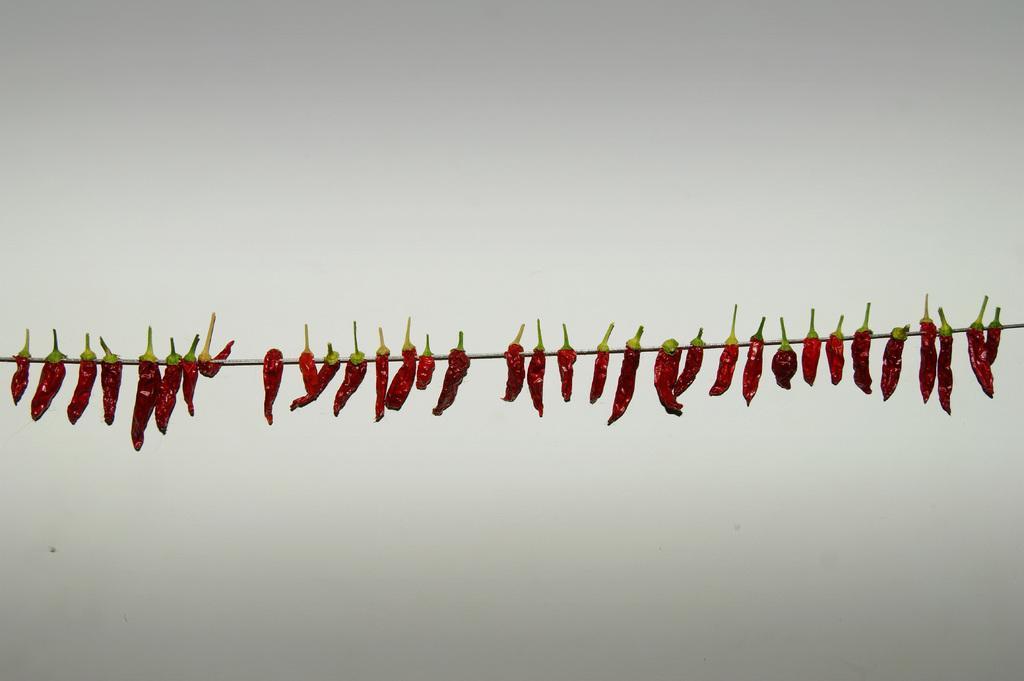How would you summarize this image in a sentence or two? In this image we can see few red chilies tied to a rope, also we can see the wall. 